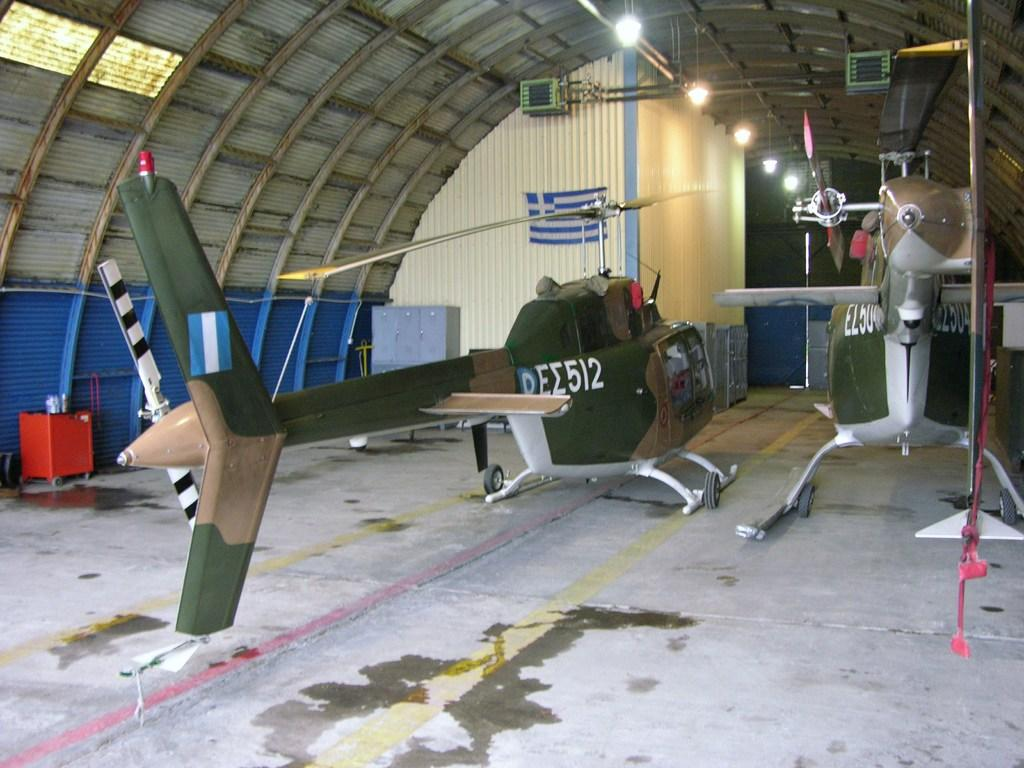What can be seen on the floor in the foreground of the image? There are helicopters on the floor in the foreground. What else is present in the foreground of the image? There are flags and metal objects in the foreground. What can be seen in the background of the image? There is a wall and lights on a rooftop in the background. Can you describe the possible setting of the image? The image might have been taken in a hall. What type of curtain is hanging from the helicopters in the image? There are no curtains present in the image; it features helicopters, flags, and metal objects on the floor, as well as a wall and lights on a rooftop in the background. What country is represented by the flags in the image? The image does not specify which country the flags represent, as it only shows the presence of flags without any identifying features. 